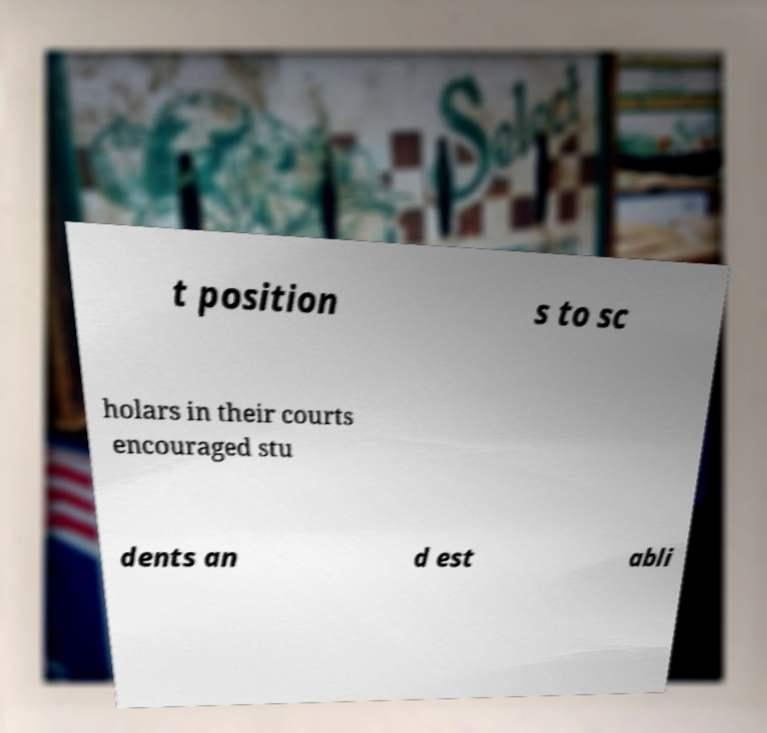Could you assist in decoding the text presented in this image and type it out clearly? t position s to sc holars in their courts encouraged stu dents an d est abli 